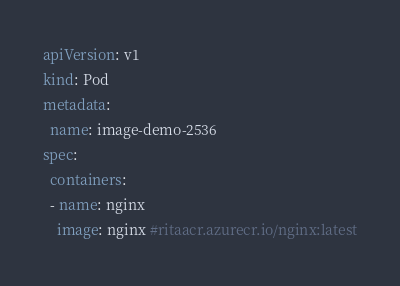<code> <loc_0><loc_0><loc_500><loc_500><_YAML_>apiVersion: v1
kind: Pod
metadata:
  name: image-demo-2536
spec:
  containers:
  - name: nginx
    image: nginx #ritaacr.azurecr.io/nginx:latest</code> 